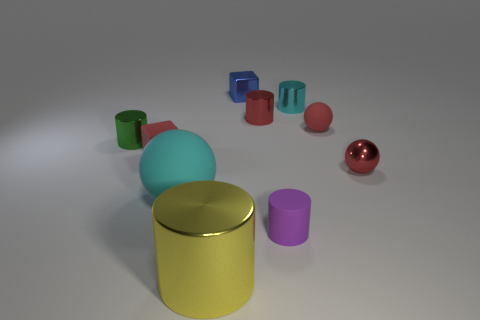Subtract all red spheres. How many were subtracted if there are1red spheres left? 1 Subtract all tiny rubber cylinders. How many cylinders are left? 4 Subtract 1 spheres. How many spheres are left? 2 Subtract all small rubber cubes. Subtract all big yellow metallic cylinders. How many objects are left? 8 Add 8 tiny cyan objects. How many tiny cyan objects are left? 9 Add 10 tiny brown metallic cubes. How many tiny brown metallic cubes exist? 10 Subtract all yellow cylinders. How many cylinders are left? 4 Subtract 0 yellow blocks. How many objects are left? 10 Subtract all balls. How many objects are left? 7 Subtract all red cubes. Subtract all gray spheres. How many cubes are left? 1 